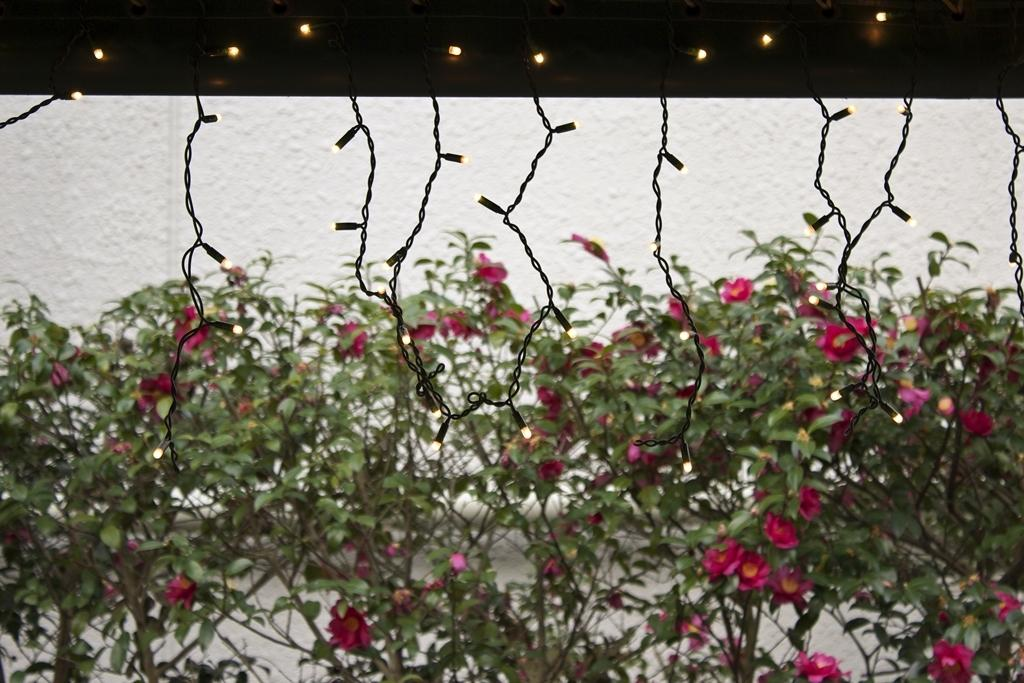What type of plants can be seen in the image? There are flower plants in the image. What color are the flowers? The flowers are pink. What can be seen in the background of the image? There is a wall and decorative lights in the background of the image. How many eggs can be seen in the image? There are no eggs present in the image. What type of teeth can be seen on the flowers in the image? Flowers do not have teeth, so this question cannot be answered. 